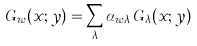<formula> <loc_0><loc_0><loc_500><loc_500>G _ { w } ( x ; y ) = \sum _ { \lambda } \alpha _ { w \lambda } \, G _ { \lambda } ( x ; y )</formula> 